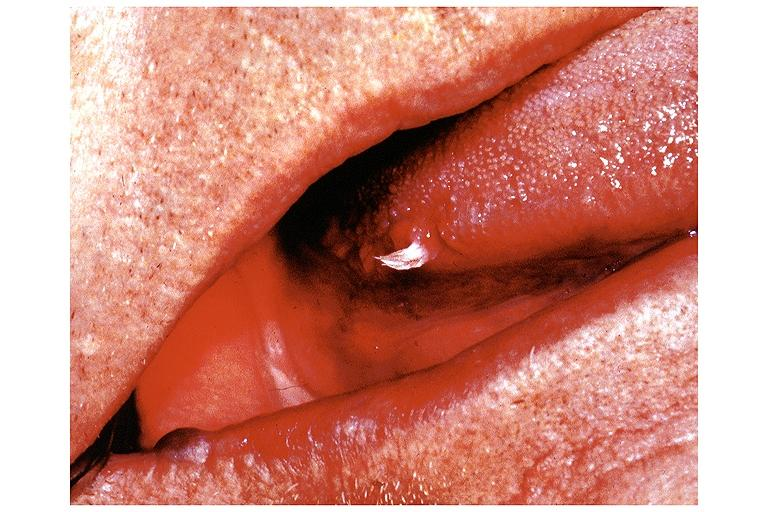does basal skull fracture show papilloma?
Answer the question using a single word or phrase. No 